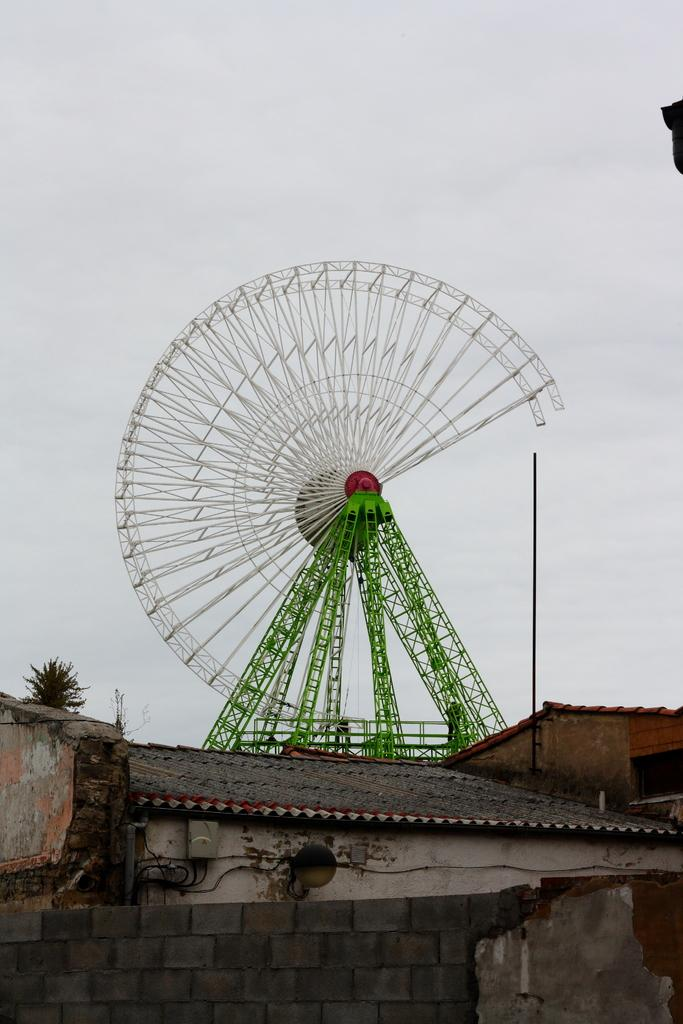What type of structures can be seen in the image? There are houses in the image. What is located in the background of the image? There is a giant wheel in the background of the image. What colors are used for the giant wheel? The giant wheel is in white and green color. What type of vegetation is present in the image? There are plants in the image. What color are the plants? The plants are green in color. What part of the natural environment is visible in the image? The sky is visible in the image. What color is the sky? The sky is in white color. What page number is the bed mentioned on in the image? There is no mention of a page or a bed in the image. What verse can be found in the image? There are no verses present in the image. 